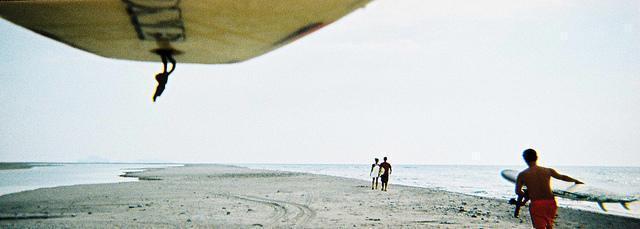How will the people here likely propel themselves upon waves?
From the following four choices, select the correct answer to address the question.
Options: Running, scuba diving, kiting, surfing. Surfing. 